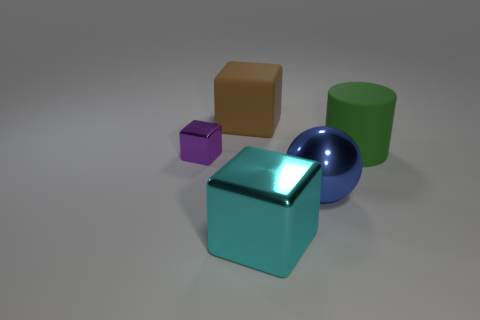What textures can be observed on the objects in the image? The objects in the image have a smooth texture, which suggests that they are likely made of a material like plastic or polished metal with a reflective surface. 